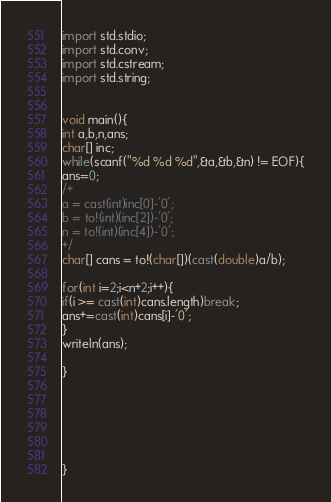Convert code to text. <code><loc_0><loc_0><loc_500><loc_500><_D_>import std.stdio;
import std.conv;
import std.cstream;
import std.string;


void main(){
int a,b,n,ans;
char[] inc;
while(scanf("%d %d %d",&a,&b,&n) != EOF){
ans=0;
/+
a = cast(int)inc[0]-'0';
b = to!(int)(inc[2])-'0';
n = to!(int)(inc[4])-'0';
+/
char[] cans = to!(char[])(cast(double)a/b);

for(int i=2;i<n+2;i++){
if(i >= cast(int)cans.length)break;
ans+=cast(int)cans[i]-'0';
}
writeln(ans);

}






}</code> 